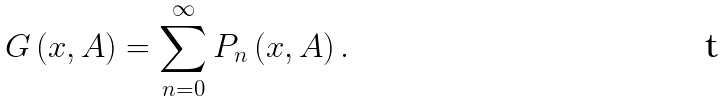Convert formula to latex. <formula><loc_0><loc_0><loc_500><loc_500>G \left ( x , A \right ) = \sum _ { n = 0 } ^ { \infty } P _ { n } \left ( x , A \right ) .</formula> 